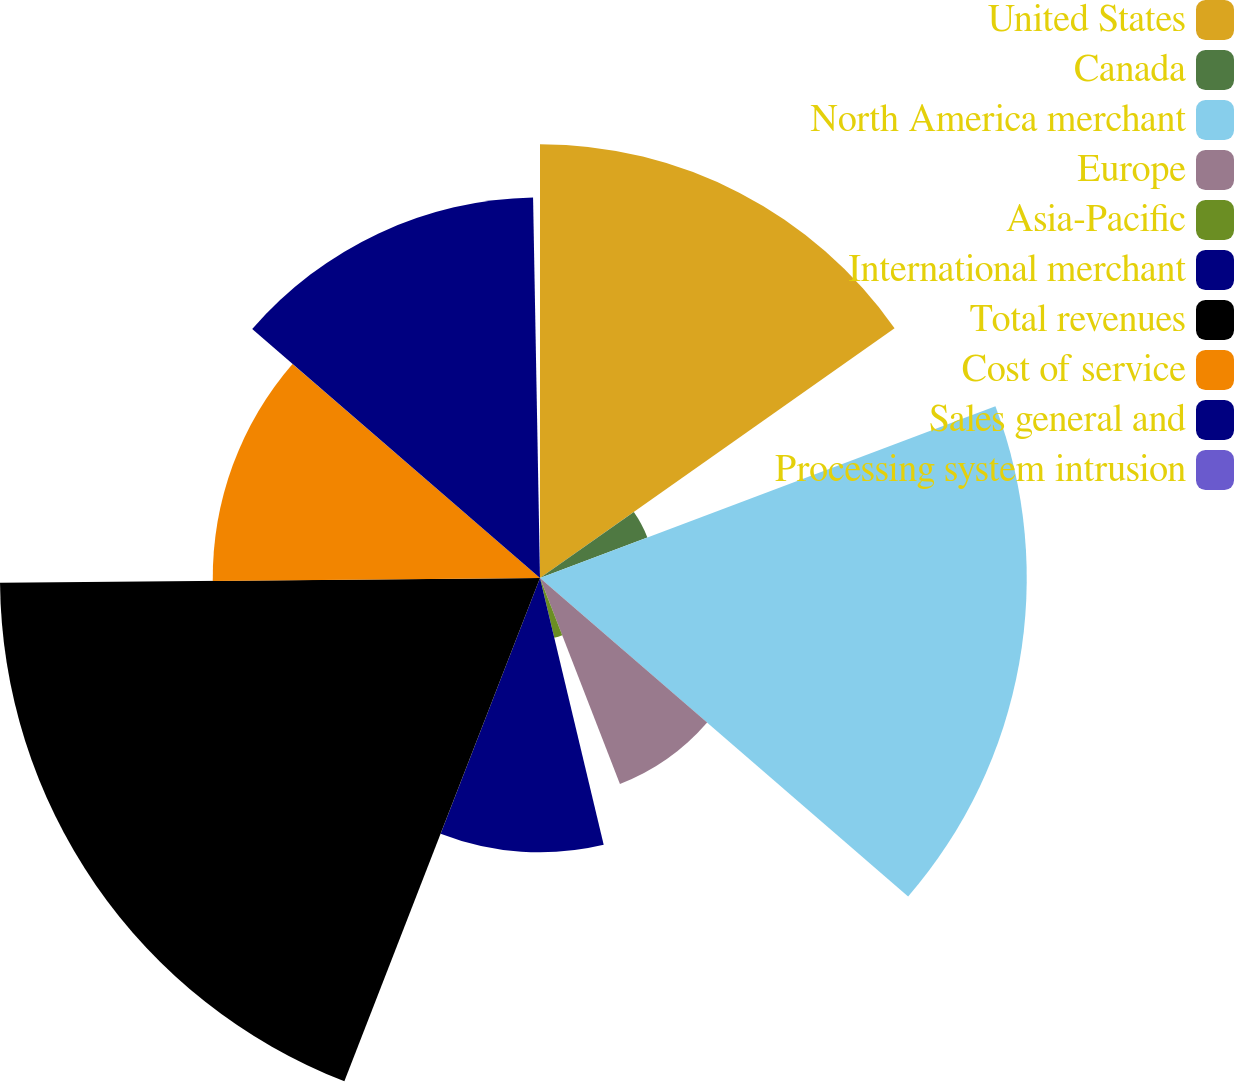Convert chart to OTSL. <chart><loc_0><loc_0><loc_500><loc_500><pie_chart><fcel>United States<fcel>Canada<fcel>North America merchant<fcel>Europe<fcel>Asia-Pacific<fcel>International merchant<fcel>Total revenues<fcel>Cost of service<fcel>Sales general and<fcel>Processing system intrusion<nl><fcel>15.23%<fcel>4.03%<fcel>17.09%<fcel>7.76%<fcel>2.16%<fcel>9.63%<fcel>18.96%<fcel>11.49%<fcel>13.36%<fcel>0.29%<nl></chart> 